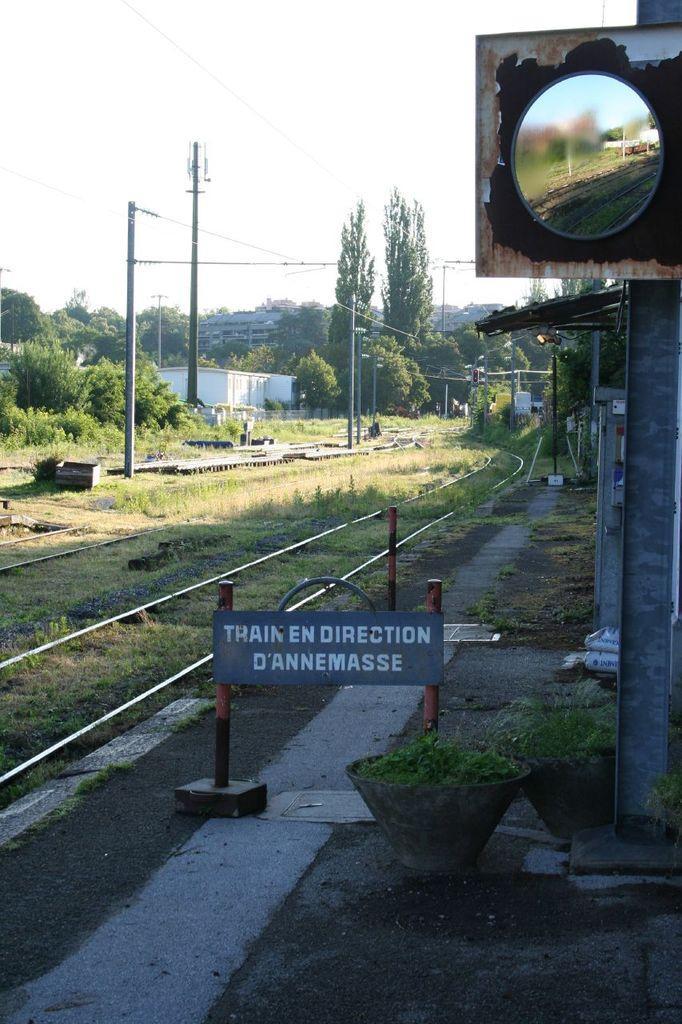Describe this image in one or two sentences. In this image I can see few railway tracks, few poles and board attached to them, few electric poles with wires to them, few trees, a metal pole with a mirror to it. In the background I can see the sky and a white colored building. 